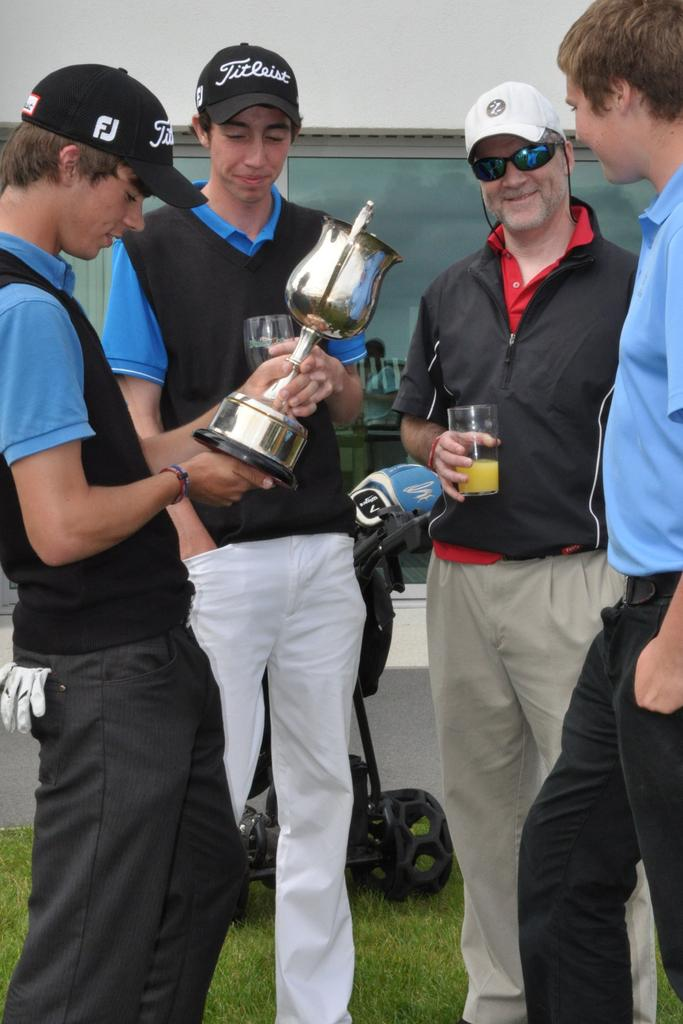<image>
Give a short and clear explanation of the subsequent image. Four men stand around admiring a golf trophy, while one of them sports a hat labeled "Titleist." 